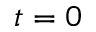<formula> <loc_0><loc_0><loc_500><loc_500>t = 0</formula> 